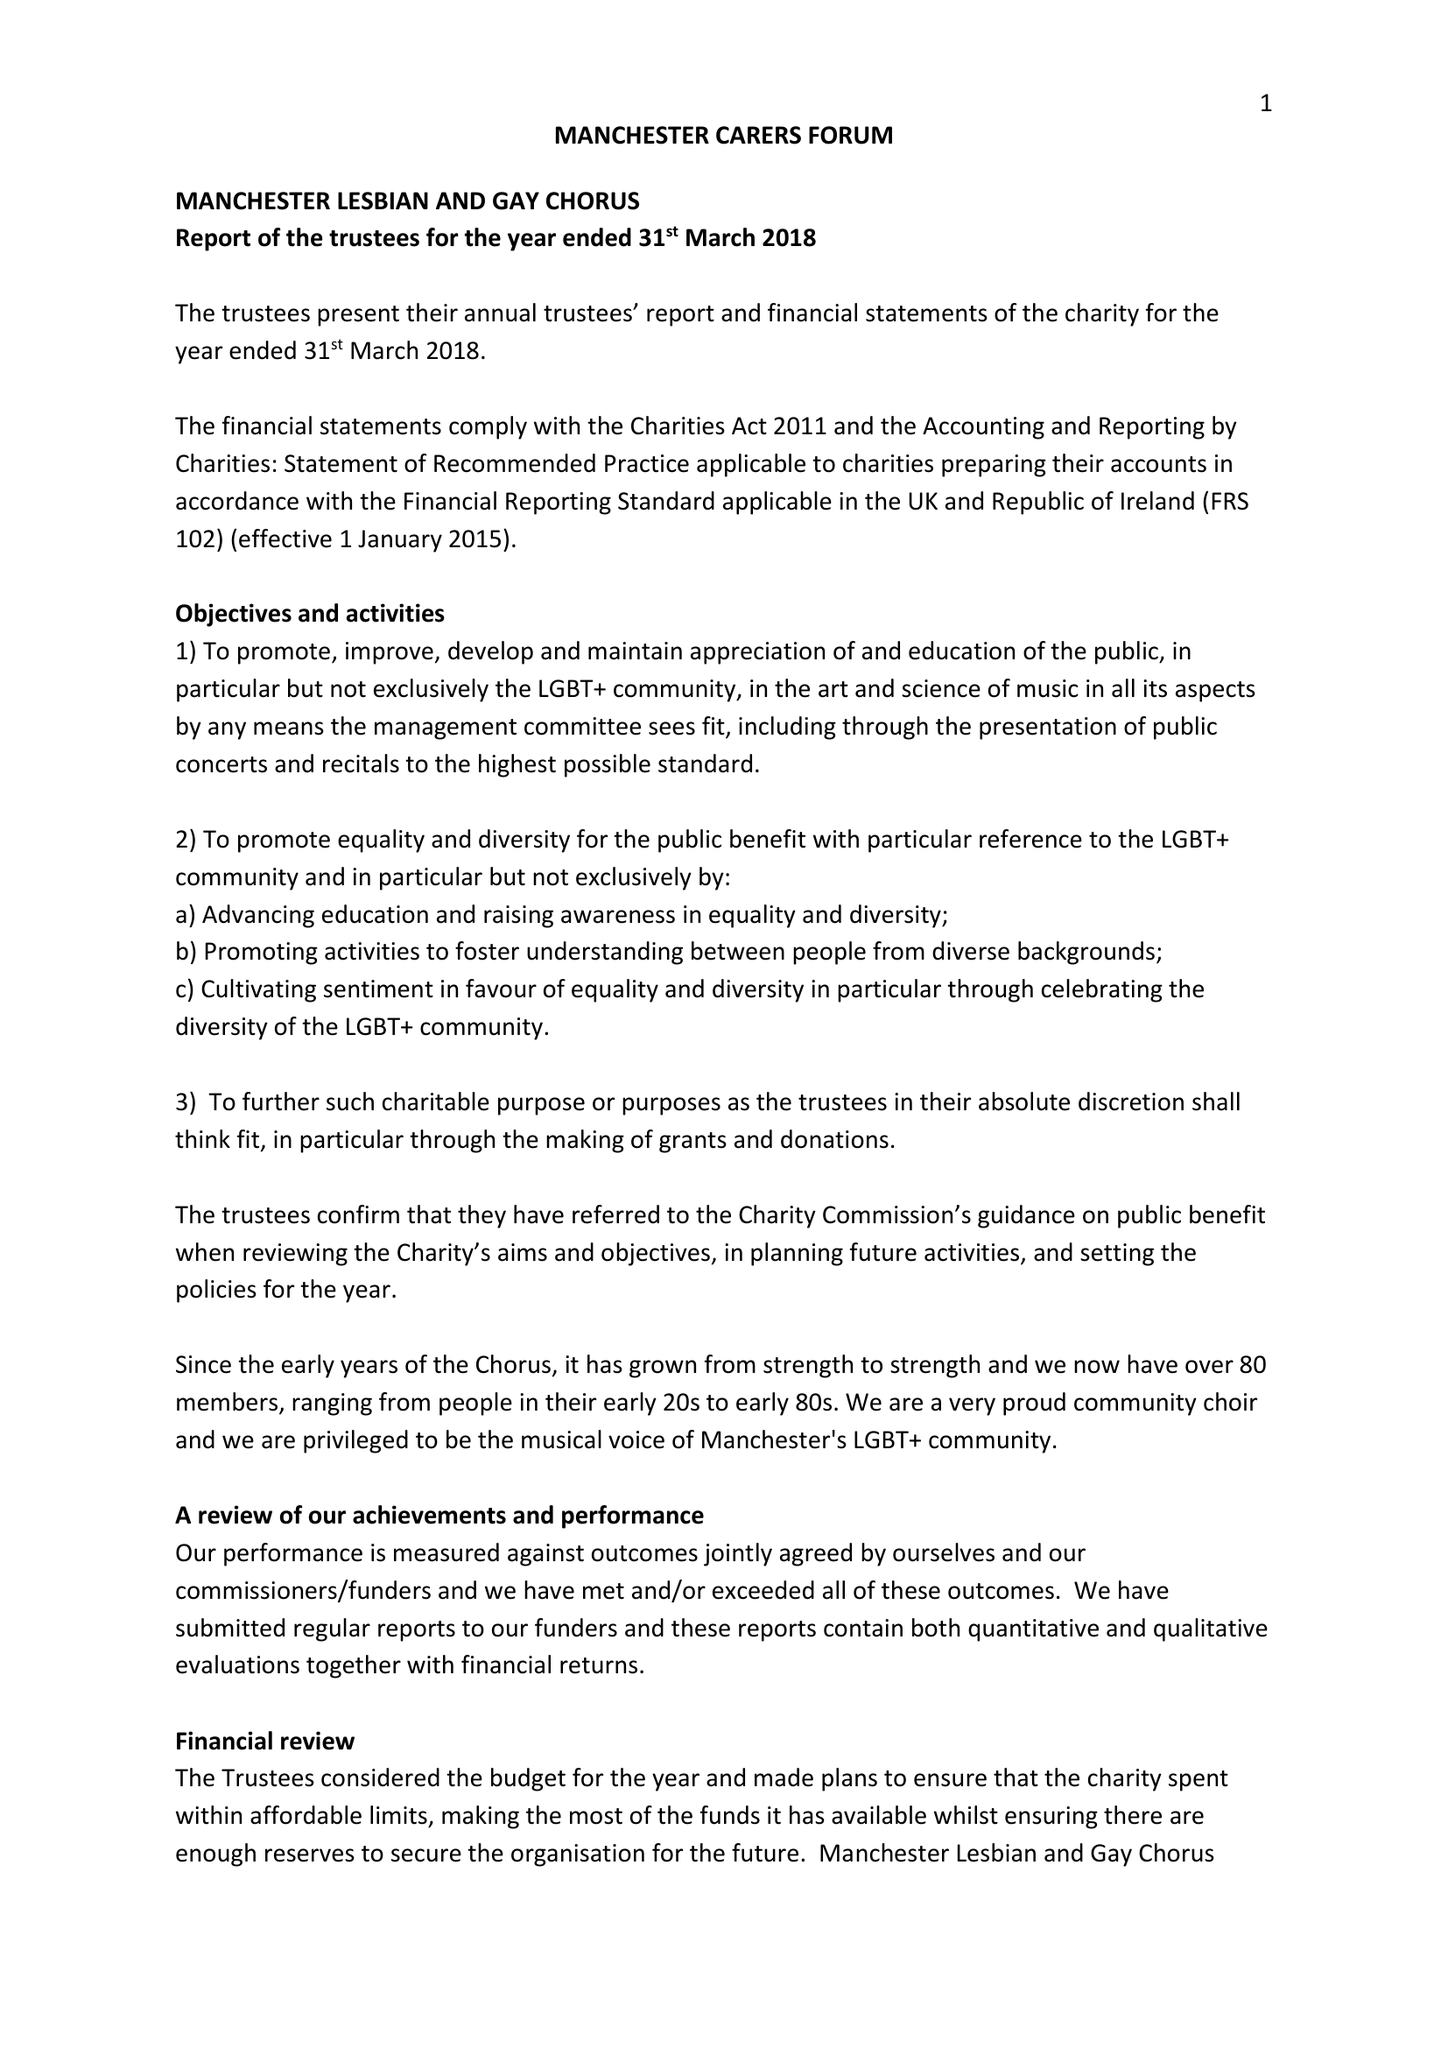What is the value for the charity_number?
Answer the question using a single word or phrase. 1169851 